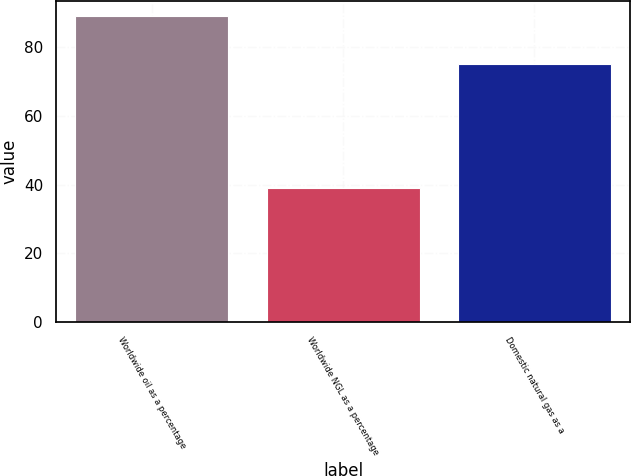Convert chart to OTSL. <chart><loc_0><loc_0><loc_500><loc_500><bar_chart><fcel>Worldwide oil as a percentage<fcel>Worldwide NGL as a percentage<fcel>Domestic natural gas as a<nl><fcel>89<fcel>39<fcel>75<nl></chart> 